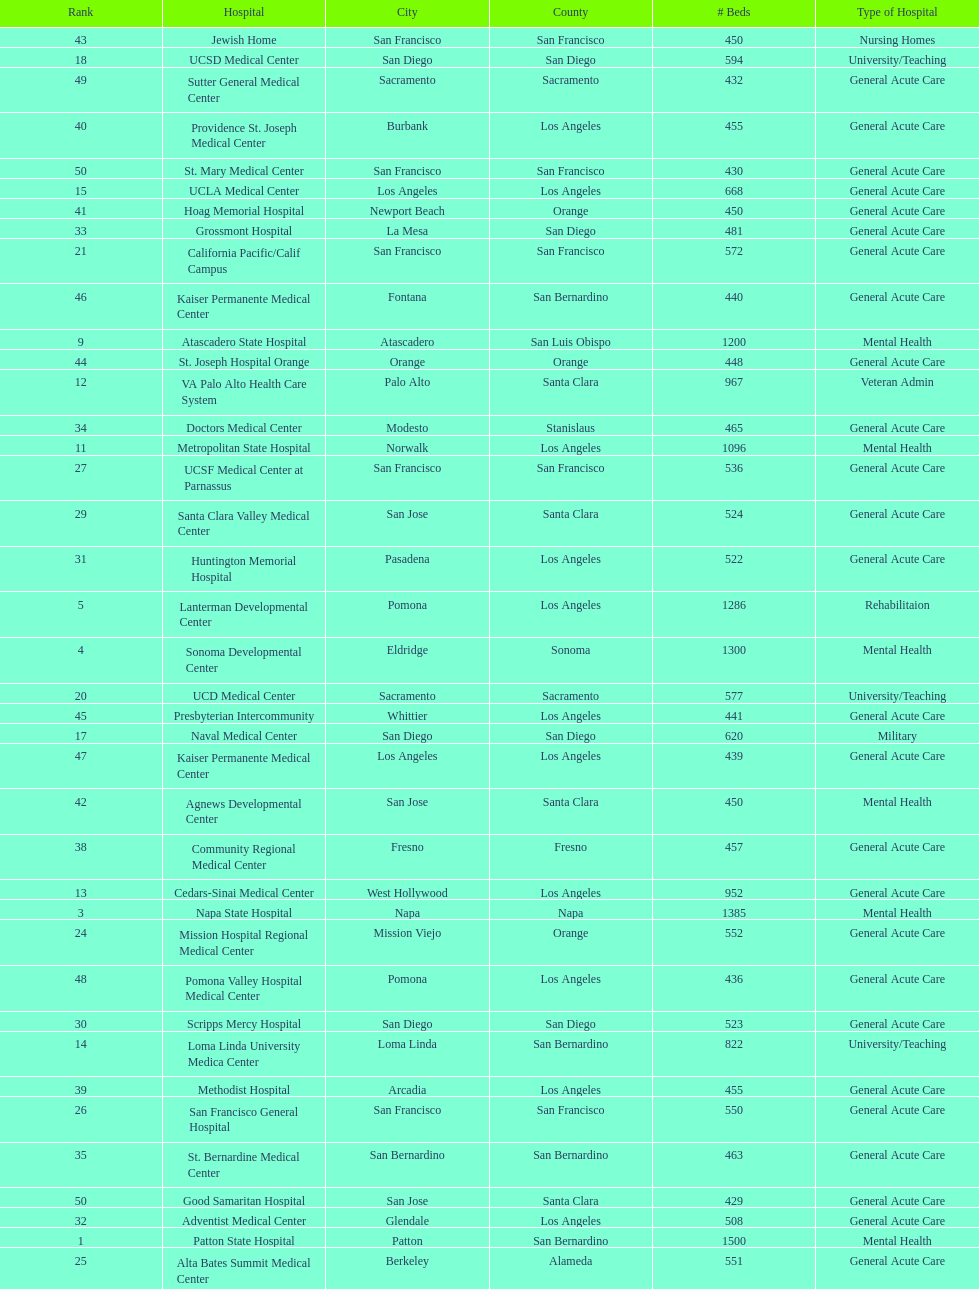How many hospitals have at least 1,000 beds? 11. 